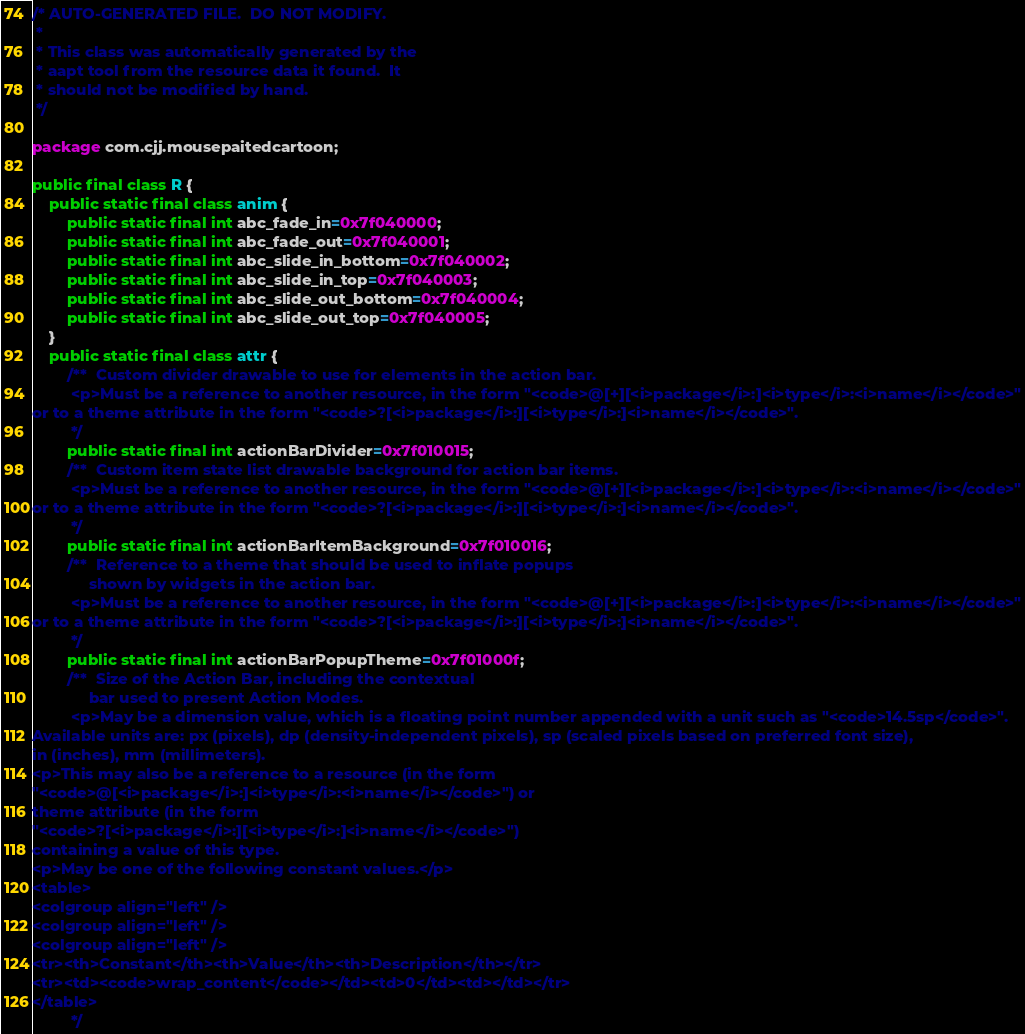<code> <loc_0><loc_0><loc_500><loc_500><_Java_>/* AUTO-GENERATED FILE.  DO NOT MODIFY.
 *
 * This class was automatically generated by the
 * aapt tool from the resource data it found.  It
 * should not be modified by hand.
 */

package com.cjj.mousepaitedcartoon;

public final class R {
    public static final class anim {
        public static final int abc_fade_in=0x7f040000;
        public static final int abc_fade_out=0x7f040001;
        public static final int abc_slide_in_bottom=0x7f040002;
        public static final int abc_slide_in_top=0x7f040003;
        public static final int abc_slide_out_bottom=0x7f040004;
        public static final int abc_slide_out_top=0x7f040005;
    }
    public static final class attr {
        /**  Custom divider drawable to use for elements in the action bar. 
         <p>Must be a reference to another resource, in the form "<code>@[+][<i>package</i>:]<i>type</i>:<i>name</i></code>"
or to a theme attribute in the form "<code>?[<i>package</i>:][<i>type</i>:]<i>name</i></code>".
         */
        public static final int actionBarDivider=0x7f010015;
        /**  Custom item state list drawable background for action bar items. 
         <p>Must be a reference to another resource, in the form "<code>@[+][<i>package</i>:]<i>type</i>:<i>name</i></code>"
or to a theme attribute in the form "<code>?[<i>package</i>:][<i>type</i>:]<i>name</i></code>".
         */
        public static final int actionBarItemBackground=0x7f010016;
        /**  Reference to a theme that should be used to inflate popups
             shown by widgets in the action bar. 
         <p>Must be a reference to another resource, in the form "<code>@[+][<i>package</i>:]<i>type</i>:<i>name</i></code>"
or to a theme attribute in the form "<code>?[<i>package</i>:][<i>type</i>:]<i>name</i></code>".
         */
        public static final int actionBarPopupTheme=0x7f01000f;
        /**  Size of the Action Bar, including the contextual
             bar used to present Action Modes. 
         <p>May be a dimension value, which is a floating point number appended with a unit such as "<code>14.5sp</code>".
Available units are: px (pixels), dp (density-independent pixels), sp (scaled pixels based on preferred font size),
in (inches), mm (millimeters).
<p>This may also be a reference to a resource (in the form
"<code>@[<i>package</i>:]<i>type</i>:<i>name</i></code>") or
theme attribute (in the form
"<code>?[<i>package</i>:][<i>type</i>:]<i>name</i></code>")
containing a value of this type.
<p>May be one of the following constant values.</p>
<table>
<colgroup align="left" />
<colgroup align="left" />
<colgroup align="left" />
<tr><th>Constant</th><th>Value</th><th>Description</th></tr>
<tr><td><code>wrap_content</code></td><td>0</td><td></td></tr>
</table>
         */</code> 